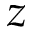Convert formula to latex. <formula><loc_0><loc_0><loc_500><loc_500>z</formula> 